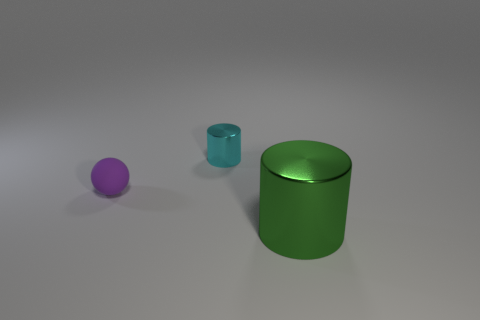Add 3 small cylinders. How many objects exist? 6 Subtract all spheres. How many objects are left? 2 Add 1 small yellow matte cylinders. How many small yellow matte cylinders exist? 1 Subtract 0 green blocks. How many objects are left? 3 Subtract all large green metal objects. Subtract all small cyan metal things. How many objects are left? 1 Add 1 spheres. How many spheres are left? 2 